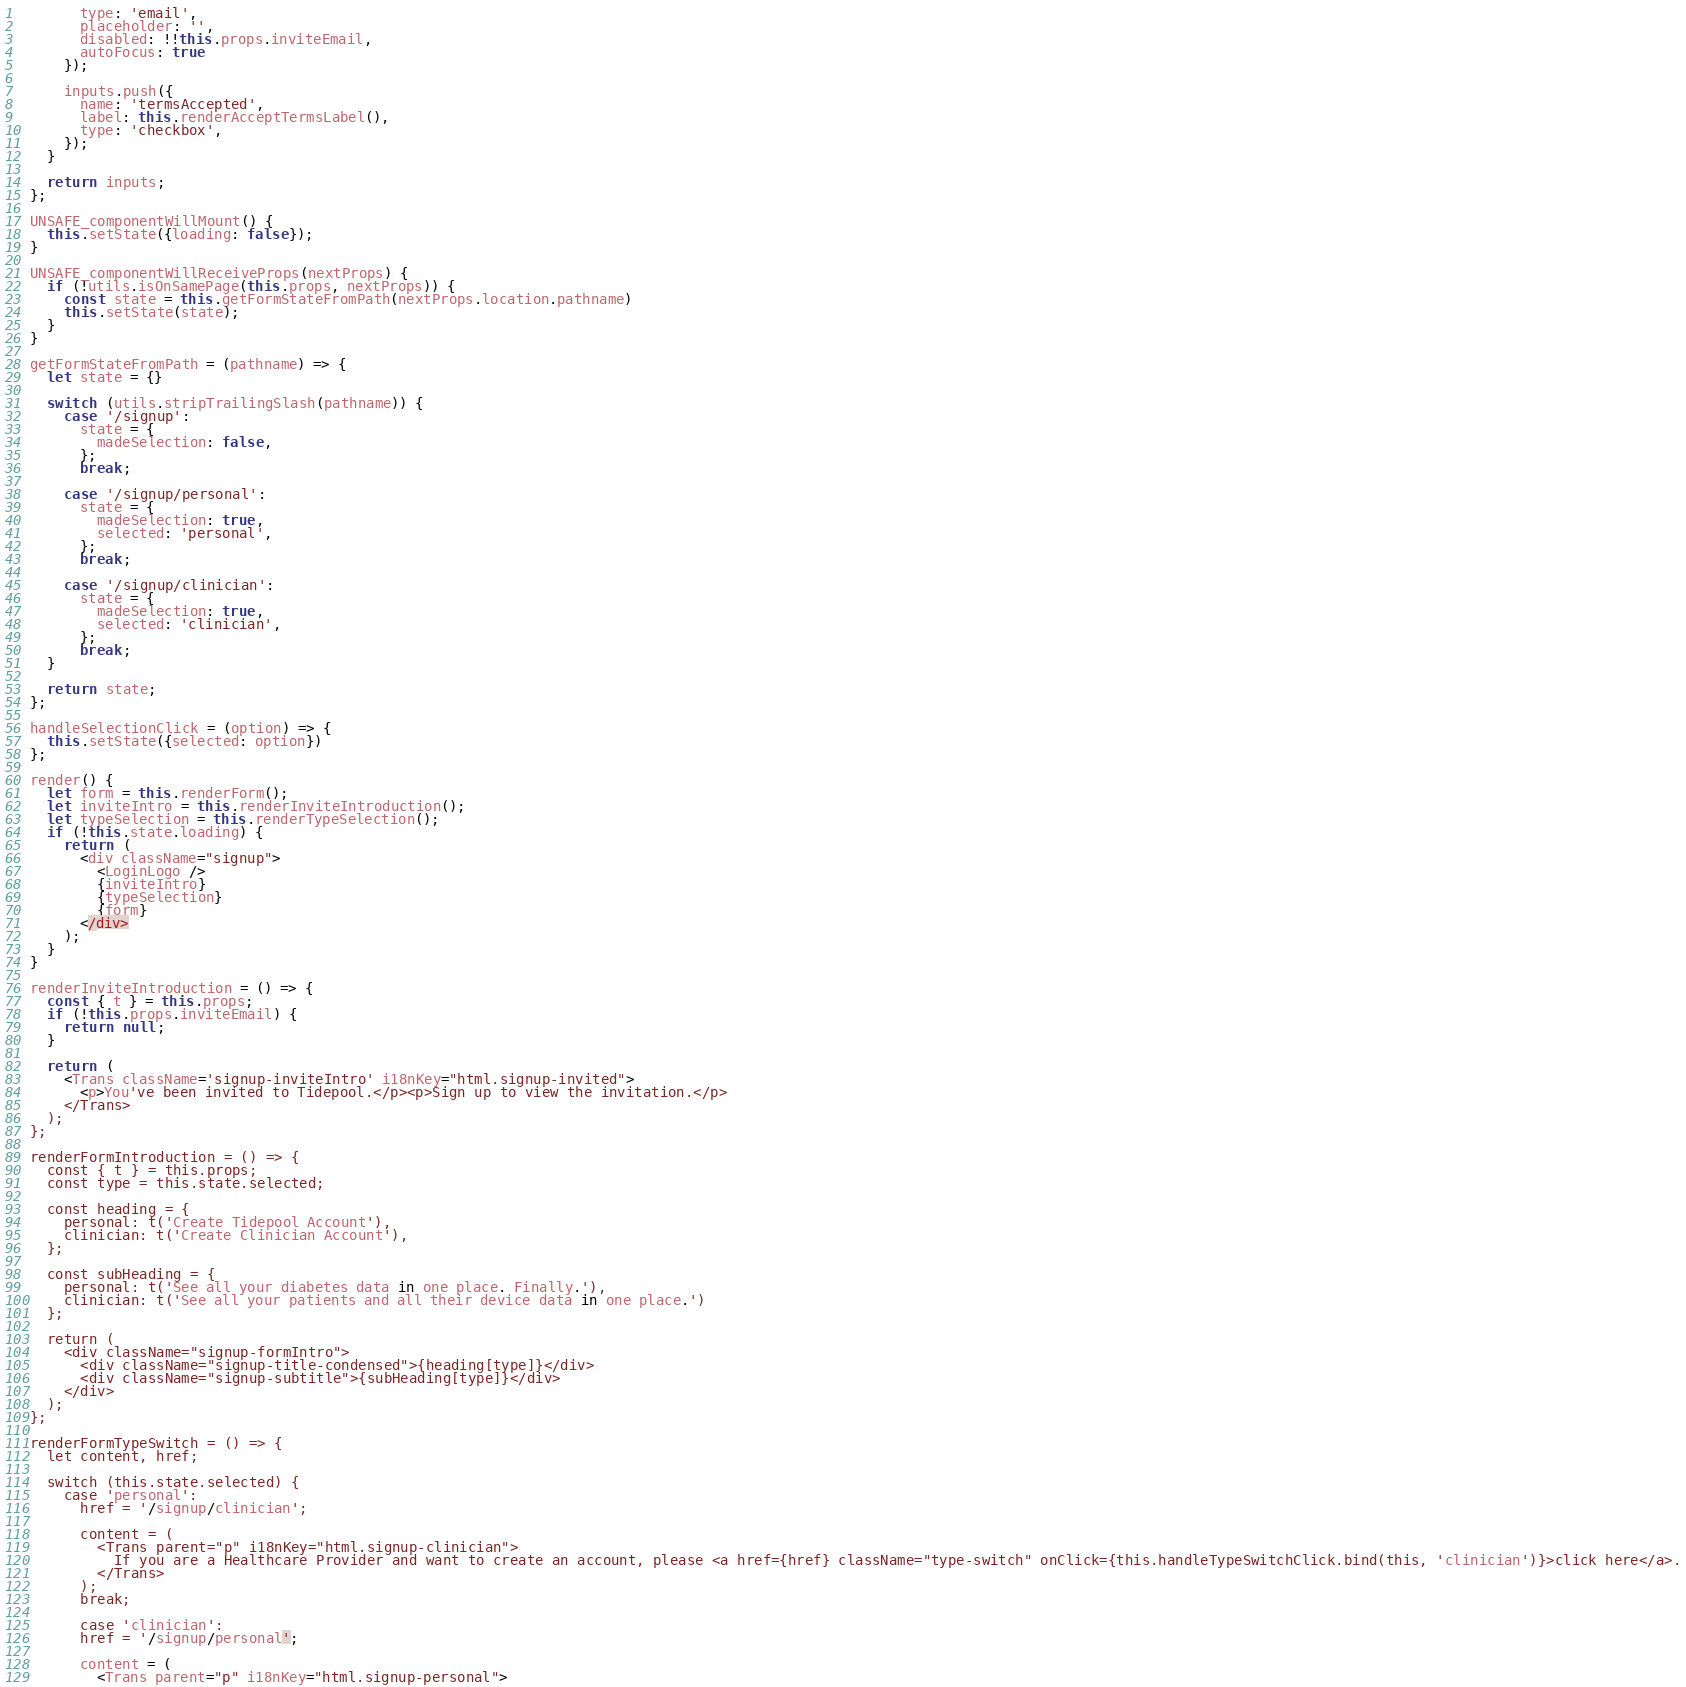Convert code to text. <code><loc_0><loc_0><loc_500><loc_500><_JavaScript_>        type: 'email',
        placeholder: '',
        disabled: !!this.props.inviteEmail,
        autoFocus: true
      });

      inputs.push({
        name: 'termsAccepted',
        label: this.renderAcceptTermsLabel(),
        type: 'checkbox',
      });
    }

    return inputs;
  };

  UNSAFE_componentWillMount() {
    this.setState({loading: false});
  }

  UNSAFE_componentWillReceiveProps(nextProps) {
    if (!utils.isOnSamePage(this.props, nextProps)) {
      const state = this.getFormStateFromPath(nextProps.location.pathname)
      this.setState(state);
    }
  }

  getFormStateFromPath = (pathname) => {
    let state = {}

    switch (utils.stripTrailingSlash(pathname)) {
      case '/signup':
        state = {
          madeSelection: false,
        };
        break;

      case '/signup/personal':
        state = {
          madeSelection: true,
          selected: 'personal',
        };
        break;

      case '/signup/clinician':
        state = {
          madeSelection: true,
          selected: 'clinician',
        };
        break;
    }

    return state;
  };

  handleSelectionClick = (option) => {
    this.setState({selected: option})
  };

  render() {
    let form = this.renderForm();
    let inviteIntro = this.renderInviteIntroduction();
    let typeSelection = this.renderTypeSelection();
    if (!this.state.loading) {
      return (
        <div className="signup">
          <LoginLogo />
          {inviteIntro}
          {typeSelection}
          {form}
        </div>
      );
    }
  }

  renderInviteIntroduction = () => {
    const { t } = this.props;
    if (!this.props.inviteEmail) {
      return null;
    }

    return (
      <Trans className='signup-inviteIntro' i18nKey="html.signup-invited">
        <p>You've been invited to Tidepool.</p><p>Sign up to view the invitation.</p>
      </Trans>
    );
  };

  renderFormIntroduction = () => {
    const { t } = this.props;
    const type = this.state.selected;

    const heading = {
      personal: t('Create Tidepool Account'),
      clinician: t('Create Clinician Account'),
    };

    const subHeading = {
      personal: t('See all your diabetes data in one place. Finally.'),
      clinician: t('See all your patients and all their device data in one place.')
    };

    return (
      <div className="signup-formIntro">
        <div className="signup-title-condensed">{heading[type]}</div>
        <div className="signup-subtitle">{subHeading[type]}</div>
      </div>
    );
  };

  renderFormTypeSwitch = () => {
    let content, href;

    switch (this.state.selected) {
      case 'personal':
        href = '/signup/clinician';

        content = (
          <Trans parent="p" i18nKey="html.signup-clinician">
            If you are a Healthcare Provider and want to create an account, please <a href={href} className="type-switch" onClick={this.handleTypeSwitchClick.bind(this, 'clinician')}>click here</a>.
          </Trans>
        );
        break;

        case 'clinician':
        href = '/signup/personal';

        content = (
          <Trans parent="p" i18nKey="html.signup-personal"></code> 